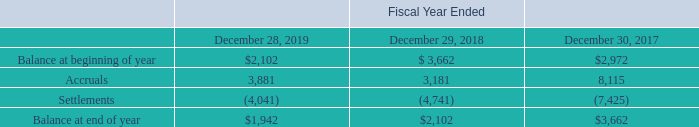Warranty Obligations
We offer warranties on certain products and record a liability for the estimated future costs associated with warranty claims at the time revenue is recognized. The warranty liability is based upon historical experience and our estimate of the level of future costs. While we engage in product quality programs and processes, our warranty obligation is affected by product failure rates, material usage and service delivery costs incurred in correcting a product failure.
We continuously monitor product returns for warranty and maintain a reserve for the related expenses based upon our historical experience and any specifically identified field failures. As we sell new products to our customers, we must exercise considerable judgment in estimating the expected failure rates. This estimating process is based on historical experience of similar products, as well as various other assumptions that we believe to be reasonable under the circumstances.
We provide for the estimated cost of product warranties at the time revenue is recognized. Warranty costs are reflected in the Consolidated Statement of Income as a Cost of revenues. A reconciliation of the changes in our warranty liability is as follows (in thousands):
What is the basis of warranty liability? Based upon historical experience and our estimate of the level of future costs. What is the change in Balance at beginning of year from Fiscal Year Ended December 28, 2019 to December 29, 2018?
Answer scale should be: thousand. 2,102-3,662
Answer: -1560. What is the change in Accruals from Fiscal Year Ended December 28, 2019 to December 29, 2018?
Answer scale should be: thousand. 3,881-3,181
Answer: 700. In which year was Accruals less than 4,000 thousands? Locate and analyze accruals in row 4
answer: 2019, 2018. What was the Settlements in 2019, 2018 and 2017 respectively?
Answer scale should be: thousand. (4,041), (4,741), (7,425). Where are the warranty costs reflected? Consolidated statement of income as a cost of revenues. 